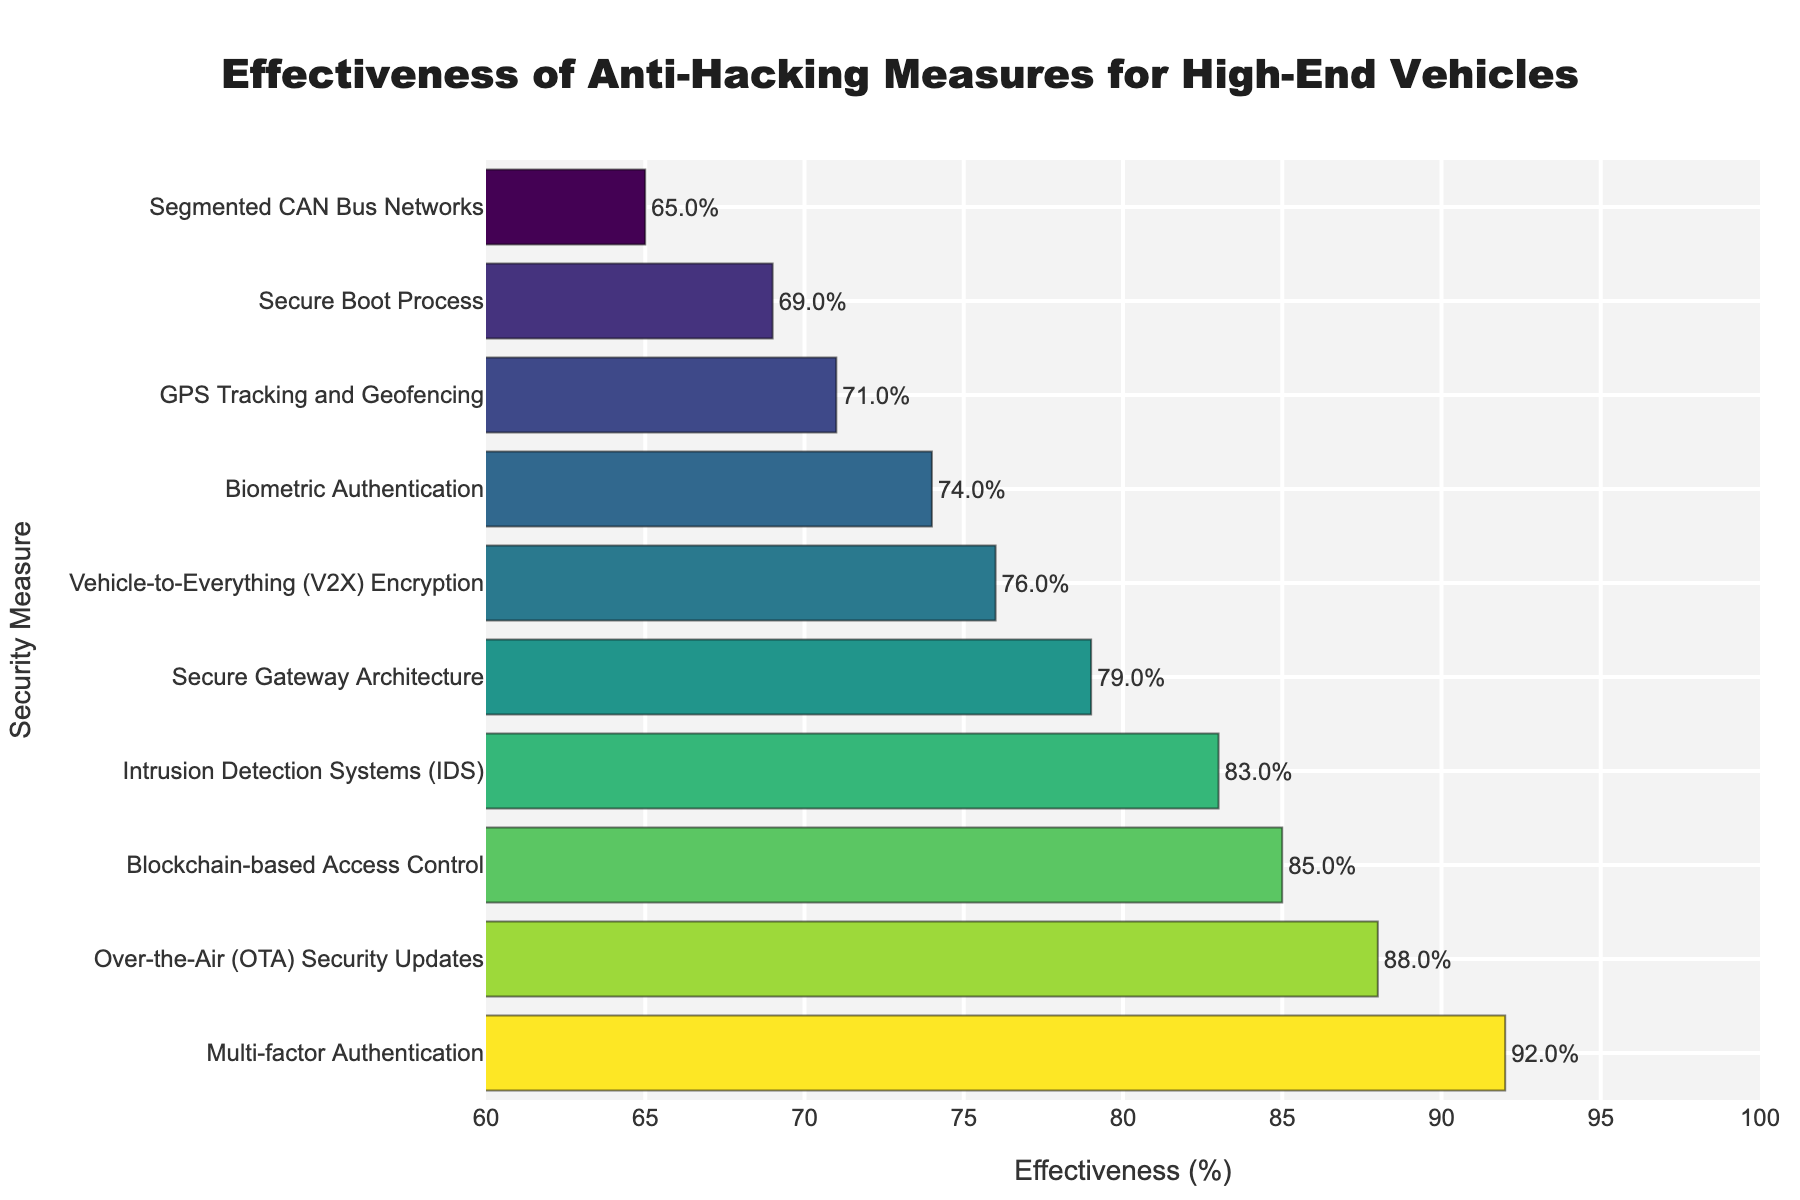Which anti-hacking measure is the most effective? By examining the figure, the bar representing "Multi-factor Authentication" has the highest value at 92%, indicating it is the most effective measure.
Answer: Multi-factor Authentication Which anti-hacking measure is the least effective? The bar for "Segmented CAN Bus Networks" is the shortest on the chart, representing the lowest effectiveness at 65%.
Answer: Segmented CAN Bus Networks What is the effectiveness range of the anti-hacking measures? The effectiveness values range from the highest at 92% ("Multi-factor Authentication") to the lowest at 65% ("Segmented CAN Bus Networks"). The range is 92% - 65%.
Answer: 27% How does the effectiveness of "Biometric Authentication" compare to "Blockchain-based Access Control"? By comparing the bar lengths, "Blockchain-based Access Control" has an effectiveness of 85%, while "Biometric Authentication" stands at 74%. Thus, "Blockchain-based Access Control" is 11% more effective.
Answer: Blockchain-based Access Control is 11% more effective What’s the average effectiveness of the top 3 most effective measures? The top 3 most effective measures are "Multi-factor Authentication" (92%), "Over-the-Air (OTA) Security Updates" (88%), and "Blockchain-based Access Control" (85%). The average is calculated as (92 + 88 + 85) / 3 = 265 / 3 = 88.33%.
Answer: 88.33% How many measures have an effectiveness of 80% or higher? Counting the bars with effectiveness percentages of 80% or above, there are 4 measures: "Multi-factor Authentication" (92%), "Over-the-Air (OTA) Security Updates" (88%), "Blockchain-based Access Control" (85%), and "Intrusion Detection Systems (IDS)" (83%).
Answer: 4 What is the combined effectiveness of "Secure Gateway Architecture" and "Biometric Authentication"? Adding the effectiveness values of "Secure Gateway Architecture" (79%) and "Biometric Authentication" (74%) gives a combined effectiveness of 79 + 74 = 153%.
Answer: 153% Which measures fall within the effectiveness range of 70%-80%? Measures in the effectiveness range of 70%-80% are "Vehicle-to-Everything (V2X) Encryption" (76%), "Biometric Authentication" (74%), and "GPS Tracking and Geofencing" (71%).
Answer: Vehicle-to-Everything (V2X) Encryption, Biometric Authentication, GPS Tracking and Geofencing By how much is "OTA Security Updates" more effective than "Intrusion Detection Systems (IDS)"? The effectiveness of "OTA Security Updates" is 88%, while "Intrusion Detection Systems (IDS)" is 83%. The difference is calculated as 88 - 83.
Answer: 5% What is the median effectiveness value of all listed measures? Sorting the effectiveness values: 65%, 69%, 71%, 74%, 76%, 79%, 83%, 85%, 88%, 92%. The median, the middle value, is the average of the 5th and 6th values (76% and 79%), calculated as (76 + 79) / 2 = 77.5%.
Answer: 77.5% 